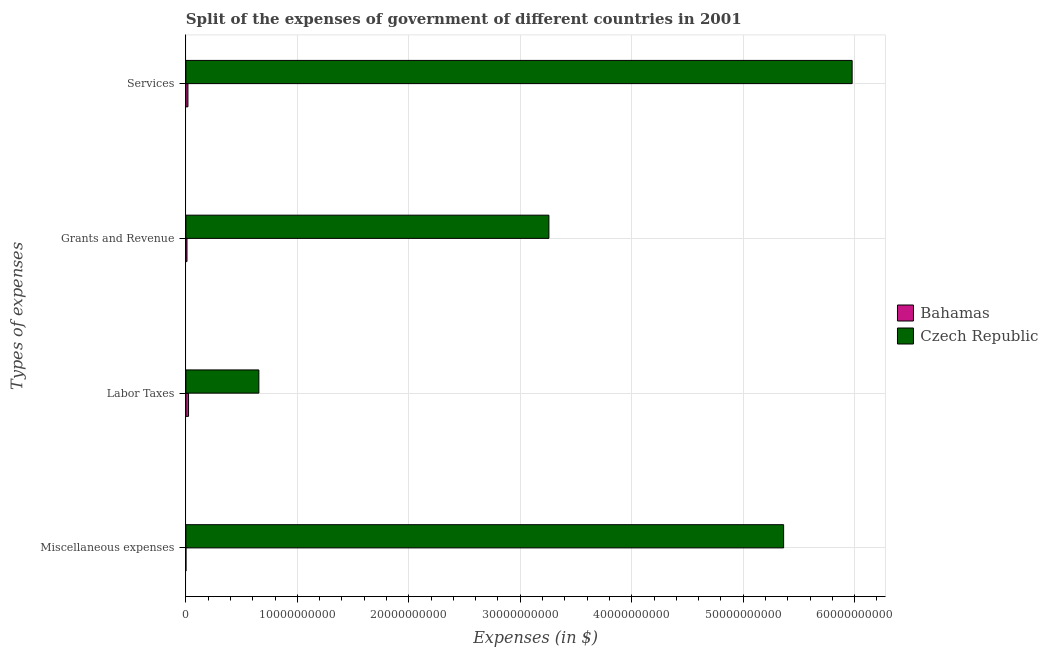How many different coloured bars are there?
Offer a terse response. 2. How many bars are there on the 4th tick from the top?
Offer a very short reply. 2. What is the label of the 1st group of bars from the top?
Give a very brief answer. Services. What is the amount spent on services in Bahamas?
Keep it short and to the point. 1.85e+08. Across all countries, what is the maximum amount spent on labor taxes?
Ensure brevity in your answer.  6.55e+09. Across all countries, what is the minimum amount spent on labor taxes?
Keep it short and to the point. 2.40e+08. In which country was the amount spent on services maximum?
Your response must be concise. Czech Republic. In which country was the amount spent on services minimum?
Offer a very short reply. Bahamas. What is the total amount spent on labor taxes in the graph?
Your answer should be compact. 6.79e+09. What is the difference between the amount spent on grants and revenue in Czech Republic and that in Bahamas?
Your response must be concise. 3.25e+1. What is the difference between the amount spent on grants and revenue in Czech Republic and the amount spent on miscellaneous expenses in Bahamas?
Your answer should be very brief. 3.26e+1. What is the average amount spent on labor taxes per country?
Provide a succinct answer. 3.39e+09. What is the difference between the amount spent on services and amount spent on miscellaneous expenses in Czech Republic?
Ensure brevity in your answer.  6.15e+09. What is the ratio of the amount spent on services in Bahamas to that in Czech Republic?
Your response must be concise. 0. What is the difference between the highest and the second highest amount spent on grants and revenue?
Ensure brevity in your answer.  3.25e+1. What is the difference between the highest and the lowest amount spent on labor taxes?
Your response must be concise. 6.31e+09. In how many countries, is the amount spent on labor taxes greater than the average amount spent on labor taxes taken over all countries?
Offer a terse response. 1. Is the sum of the amount spent on services in Czech Republic and Bahamas greater than the maximum amount spent on miscellaneous expenses across all countries?
Your answer should be very brief. Yes. Is it the case that in every country, the sum of the amount spent on grants and revenue and amount spent on services is greater than the sum of amount spent on labor taxes and amount spent on miscellaneous expenses?
Give a very brief answer. No. What does the 2nd bar from the top in Grants and Revenue represents?
Give a very brief answer. Bahamas. What does the 1st bar from the bottom in Labor Taxes represents?
Offer a very short reply. Bahamas. Are all the bars in the graph horizontal?
Offer a very short reply. Yes. What is the difference between two consecutive major ticks on the X-axis?
Your answer should be very brief. 1.00e+1. Are the values on the major ticks of X-axis written in scientific E-notation?
Make the answer very short. No. How many legend labels are there?
Give a very brief answer. 2. How are the legend labels stacked?
Give a very brief answer. Vertical. What is the title of the graph?
Keep it short and to the point. Split of the expenses of government of different countries in 2001. Does "Cyprus" appear as one of the legend labels in the graph?
Keep it short and to the point. No. What is the label or title of the X-axis?
Your answer should be very brief. Expenses (in $). What is the label or title of the Y-axis?
Ensure brevity in your answer.  Types of expenses. What is the Expenses (in $) of Bahamas in Miscellaneous expenses?
Provide a short and direct response. 3.20e+06. What is the Expenses (in $) in Czech Republic in Miscellaneous expenses?
Give a very brief answer. 5.36e+1. What is the Expenses (in $) of Bahamas in Labor Taxes?
Your answer should be compact. 2.40e+08. What is the Expenses (in $) in Czech Republic in Labor Taxes?
Your response must be concise. 6.55e+09. What is the Expenses (in $) in Bahamas in Grants and Revenue?
Your answer should be very brief. 9.94e+07. What is the Expenses (in $) in Czech Republic in Grants and Revenue?
Offer a very short reply. 3.26e+1. What is the Expenses (in $) in Bahamas in Services?
Your answer should be very brief. 1.85e+08. What is the Expenses (in $) of Czech Republic in Services?
Give a very brief answer. 5.98e+1. Across all Types of expenses, what is the maximum Expenses (in $) in Bahamas?
Your response must be concise. 2.40e+08. Across all Types of expenses, what is the maximum Expenses (in $) of Czech Republic?
Keep it short and to the point. 5.98e+1. Across all Types of expenses, what is the minimum Expenses (in $) of Bahamas?
Make the answer very short. 3.20e+06. Across all Types of expenses, what is the minimum Expenses (in $) in Czech Republic?
Give a very brief answer. 6.55e+09. What is the total Expenses (in $) of Bahamas in the graph?
Offer a very short reply. 5.27e+08. What is the total Expenses (in $) of Czech Republic in the graph?
Provide a succinct answer. 1.53e+11. What is the difference between the Expenses (in $) in Bahamas in Miscellaneous expenses and that in Labor Taxes?
Keep it short and to the point. -2.37e+08. What is the difference between the Expenses (in $) of Czech Republic in Miscellaneous expenses and that in Labor Taxes?
Offer a very short reply. 4.71e+1. What is the difference between the Expenses (in $) in Bahamas in Miscellaneous expenses and that in Grants and Revenue?
Keep it short and to the point. -9.62e+07. What is the difference between the Expenses (in $) of Czech Republic in Miscellaneous expenses and that in Grants and Revenue?
Your answer should be compact. 2.11e+1. What is the difference between the Expenses (in $) of Bahamas in Miscellaneous expenses and that in Services?
Offer a very short reply. -1.82e+08. What is the difference between the Expenses (in $) of Czech Republic in Miscellaneous expenses and that in Services?
Make the answer very short. -6.15e+09. What is the difference between the Expenses (in $) in Bahamas in Labor Taxes and that in Grants and Revenue?
Make the answer very short. 1.41e+08. What is the difference between the Expenses (in $) in Czech Republic in Labor Taxes and that in Grants and Revenue?
Offer a very short reply. -2.60e+1. What is the difference between the Expenses (in $) of Bahamas in Labor Taxes and that in Services?
Make the answer very short. 5.52e+07. What is the difference between the Expenses (in $) in Czech Republic in Labor Taxes and that in Services?
Give a very brief answer. -5.32e+1. What is the difference between the Expenses (in $) in Bahamas in Grants and Revenue and that in Services?
Ensure brevity in your answer.  -8.54e+07. What is the difference between the Expenses (in $) of Czech Republic in Grants and Revenue and that in Services?
Provide a short and direct response. -2.72e+1. What is the difference between the Expenses (in $) of Bahamas in Miscellaneous expenses and the Expenses (in $) of Czech Republic in Labor Taxes?
Your answer should be very brief. -6.54e+09. What is the difference between the Expenses (in $) of Bahamas in Miscellaneous expenses and the Expenses (in $) of Czech Republic in Grants and Revenue?
Your answer should be compact. -3.26e+1. What is the difference between the Expenses (in $) of Bahamas in Miscellaneous expenses and the Expenses (in $) of Czech Republic in Services?
Your response must be concise. -5.98e+1. What is the difference between the Expenses (in $) in Bahamas in Labor Taxes and the Expenses (in $) in Czech Republic in Grants and Revenue?
Make the answer very short. -3.23e+1. What is the difference between the Expenses (in $) in Bahamas in Labor Taxes and the Expenses (in $) in Czech Republic in Services?
Your response must be concise. -5.95e+1. What is the difference between the Expenses (in $) in Bahamas in Grants and Revenue and the Expenses (in $) in Czech Republic in Services?
Ensure brevity in your answer.  -5.97e+1. What is the average Expenses (in $) in Bahamas per Types of expenses?
Your answer should be very brief. 1.32e+08. What is the average Expenses (in $) in Czech Republic per Types of expenses?
Provide a succinct answer. 3.81e+1. What is the difference between the Expenses (in $) in Bahamas and Expenses (in $) in Czech Republic in Miscellaneous expenses?
Make the answer very short. -5.36e+1. What is the difference between the Expenses (in $) in Bahamas and Expenses (in $) in Czech Republic in Labor Taxes?
Your response must be concise. -6.31e+09. What is the difference between the Expenses (in $) in Bahamas and Expenses (in $) in Czech Republic in Grants and Revenue?
Your answer should be compact. -3.25e+1. What is the difference between the Expenses (in $) in Bahamas and Expenses (in $) in Czech Republic in Services?
Make the answer very short. -5.96e+1. What is the ratio of the Expenses (in $) in Bahamas in Miscellaneous expenses to that in Labor Taxes?
Your answer should be very brief. 0.01. What is the ratio of the Expenses (in $) of Czech Republic in Miscellaneous expenses to that in Labor Taxes?
Give a very brief answer. 8.19. What is the ratio of the Expenses (in $) in Bahamas in Miscellaneous expenses to that in Grants and Revenue?
Provide a short and direct response. 0.03. What is the ratio of the Expenses (in $) of Czech Republic in Miscellaneous expenses to that in Grants and Revenue?
Give a very brief answer. 1.65. What is the ratio of the Expenses (in $) of Bahamas in Miscellaneous expenses to that in Services?
Your answer should be compact. 0.02. What is the ratio of the Expenses (in $) of Czech Republic in Miscellaneous expenses to that in Services?
Offer a terse response. 0.9. What is the ratio of the Expenses (in $) of Bahamas in Labor Taxes to that in Grants and Revenue?
Provide a short and direct response. 2.41. What is the ratio of the Expenses (in $) of Czech Republic in Labor Taxes to that in Grants and Revenue?
Provide a short and direct response. 0.2. What is the ratio of the Expenses (in $) of Bahamas in Labor Taxes to that in Services?
Provide a short and direct response. 1.3. What is the ratio of the Expenses (in $) in Czech Republic in Labor Taxes to that in Services?
Provide a succinct answer. 0.11. What is the ratio of the Expenses (in $) of Bahamas in Grants and Revenue to that in Services?
Offer a very short reply. 0.54. What is the ratio of the Expenses (in $) of Czech Republic in Grants and Revenue to that in Services?
Your answer should be compact. 0.54. What is the difference between the highest and the second highest Expenses (in $) in Bahamas?
Provide a succinct answer. 5.52e+07. What is the difference between the highest and the second highest Expenses (in $) in Czech Republic?
Make the answer very short. 6.15e+09. What is the difference between the highest and the lowest Expenses (in $) of Bahamas?
Offer a terse response. 2.37e+08. What is the difference between the highest and the lowest Expenses (in $) in Czech Republic?
Provide a short and direct response. 5.32e+1. 